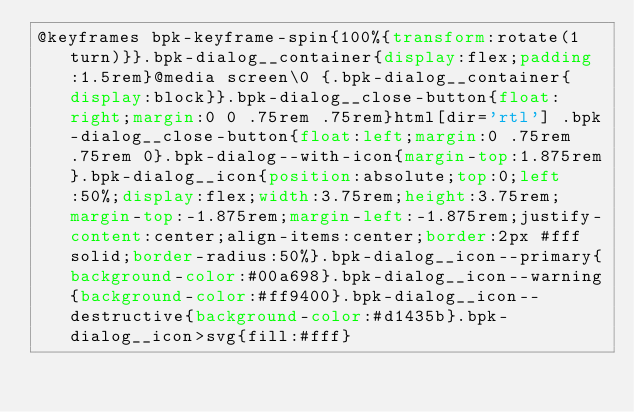Convert code to text. <code><loc_0><loc_0><loc_500><loc_500><_CSS_>@keyframes bpk-keyframe-spin{100%{transform:rotate(1turn)}}.bpk-dialog__container{display:flex;padding:1.5rem}@media screen\0 {.bpk-dialog__container{display:block}}.bpk-dialog__close-button{float:right;margin:0 0 .75rem .75rem}html[dir='rtl'] .bpk-dialog__close-button{float:left;margin:0 .75rem .75rem 0}.bpk-dialog--with-icon{margin-top:1.875rem}.bpk-dialog__icon{position:absolute;top:0;left:50%;display:flex;width:3.75rem;height:3.75rem;margin-top:-1.875rem;margin-left:-1.875rem;justify-content:center;align-items:center;border:2px #fff solid;border-radius:50%}.bpk-dialog__icon--primary{background-color:#00a698}.bpk-dialog__icon--warning{background-color:#ff9400}.bpk-dialog__icon--destructive{background-color:#d1435b}.bpk-dialog__icon>svg{fill:#fff}
</code> 